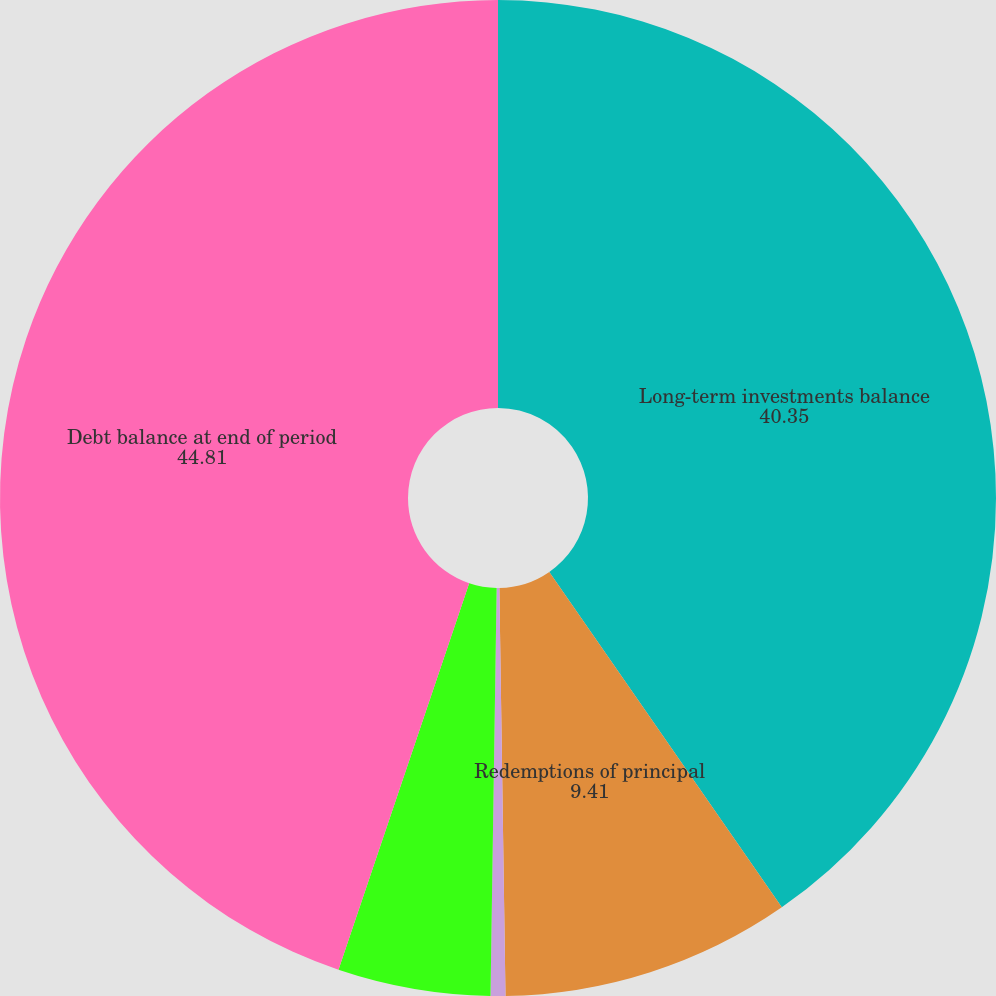Convert chart to OTSL. <chart><loc_0><loc_0><loc_500><loc_500><pie_chart><fcel>Long-term investments balance<fcel>Redemptions of principal<fcel>Foreign exchange translation<fcel>Accretion of promissory note<fcel>Debt balance at end of period<nl><fcel>40.35%<fcel>9.41%<fcel>0.48%<fcel>4.95%<fcel>44.81%<nl></chart> 